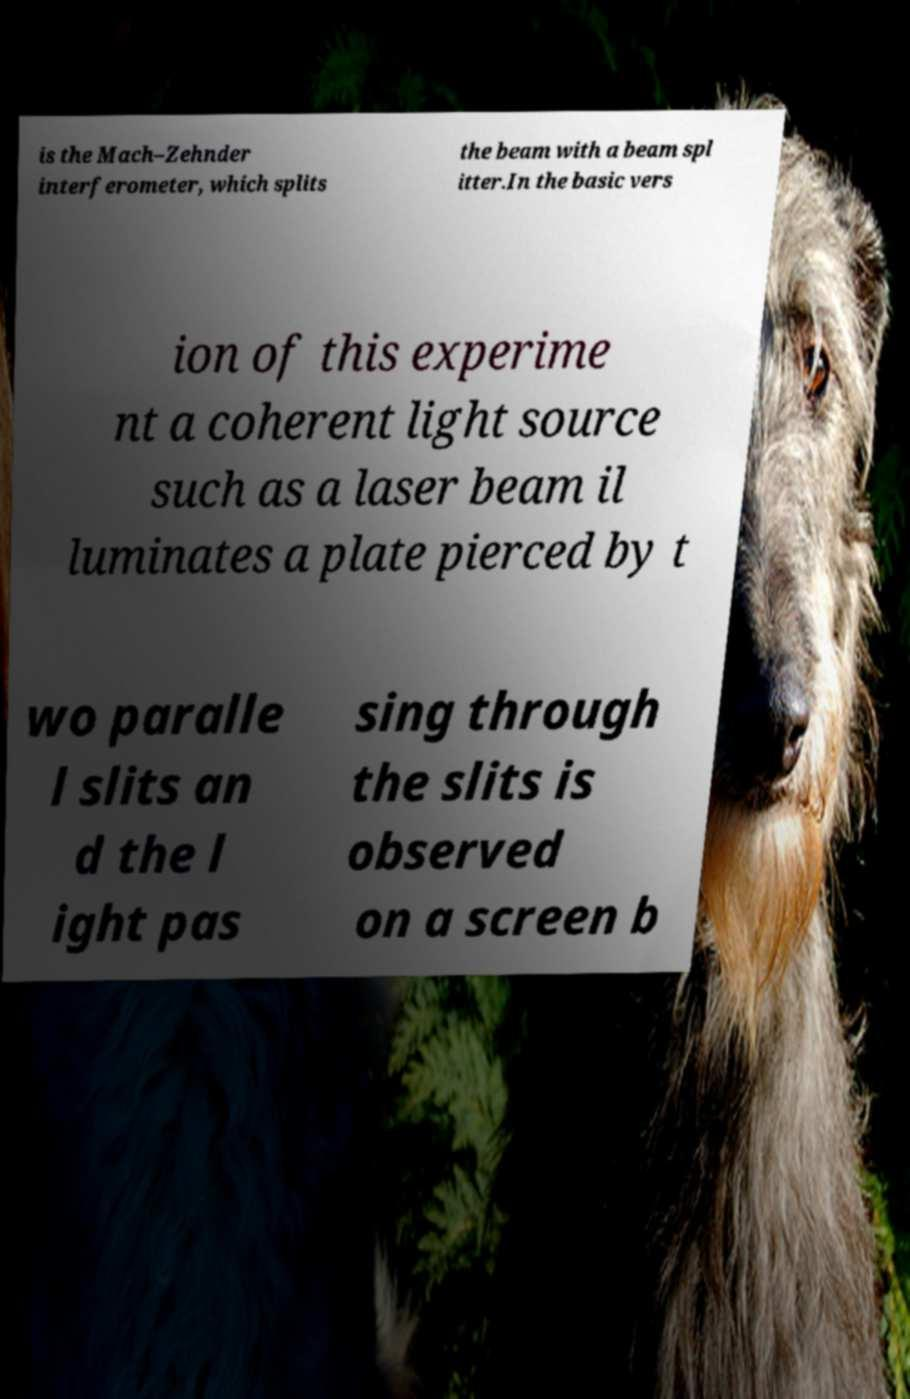Could you assist in decoding the text presented in this image and type it out clearly? is the Mach–Zehnder interferometer, which splits the beam with a beam spl itter.In the basic vers ion of this experime nt a coherent light source such as a laser beam il luminates a plate pierced by t wo paralle l slits an d the l ight pas sing through the slits is observed on a screen b 